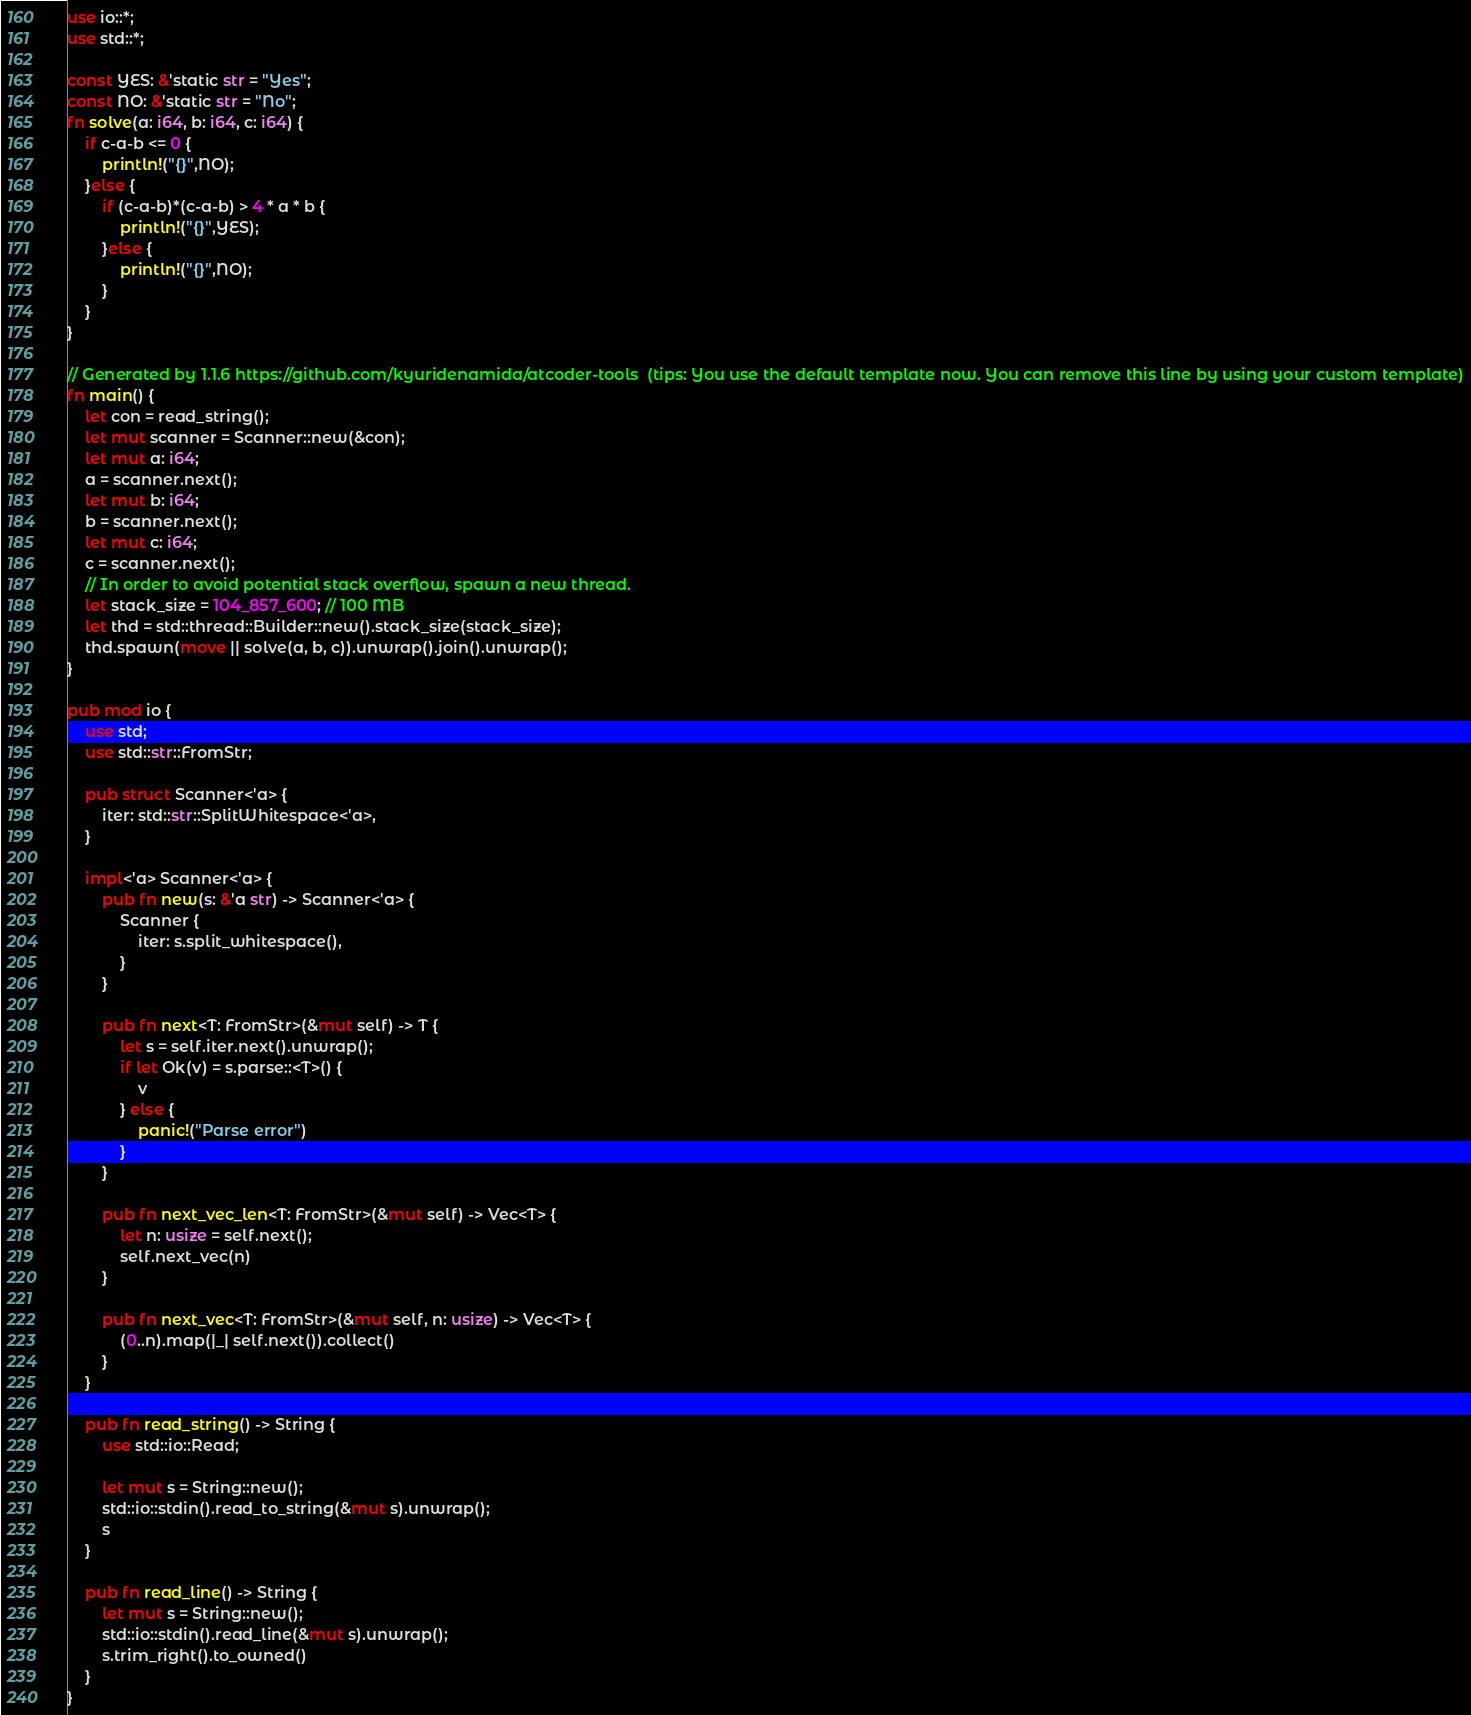Convert code to text. <code><loc_0><loc_0><loc_500><loc_500><_Rust_>use io::*;
use std::*;

const YES: &'static str = "Yes";
const NO: &'static str = "No";
fn solve(a: i64, b: i64, c: i64) {
    if c-a-b <= 0 {
        println!("{}",NO);
    }else {
        if (c-a-b)*(c-a-b) > 4 * a * b {
            println!("{}",YES);
        }else {
            println!("{}",NO);
        }
    }
}

// Generated by 1.1.6 https://github.com/kyuridenamida/atcoder-tools  (tips: You use the default template now. You can remove this line by using your custom template)
fn main() {
    let con = read_string();
    let mut scanner = Scanner::new(&con);
    let mut a: i64;
    a = scanner.next();
    let mut b: i64;
    b = scanner.next();
    let mut c: i64;
    c = scanner.next();
    // In order to avoid potential stack overflow, spawn a new thread.
    let stack_size = 104_857_600; // 100 MB
    let thd = std::thread::Builder::new().stack_size(stack_size);
    thd.spawn(move || solve(a, b, c)).unwrap().join().unwrap();
}

pub mod io {
    use std;
    use std::str::FromStr;

    pub struct Scanner<'a> {
        iter: std::str::SplitWhitespace<'a>,
    }

    impl<'a> Scanner<'a> {
        pub fn new(s: &'a str) -> Scanner<'a> {
            Scanner {
                iter: s.split_whitespace(),
            }
        }

        pub fn next<T: FromStr>(&mut self) -> T {
            let s = self.iter.next().unwrap();
            if let Ok(v) = s.parse::<T>() {
                v
            } else {
                panic!("Parse error")
            }
        }

        pub fn next_vec_len<T: FromStr>(&mut self) -> Vec<T> {
            let n: usize = self.next();
            self.next_vec(n)
        }

        pub fn next_vec<T: FromStr>(&mut self, n: usize) -> Vec<T> {
            (0..n).map(|_| self.next()).collect()
        }
    }

    pub fn read_string() -> String {
        use std::io::Read;

        let mut s = String::new();
        std::io::stdin().read_to_string(&mut s).unwrap();
        s
    }

    pub fn read_line() -> String {
        let mut s = String::new();
        std::io::stdin().read_line(&mut s).unwrap();
        s.trim_right().to_owned()
    }
}
</code> 